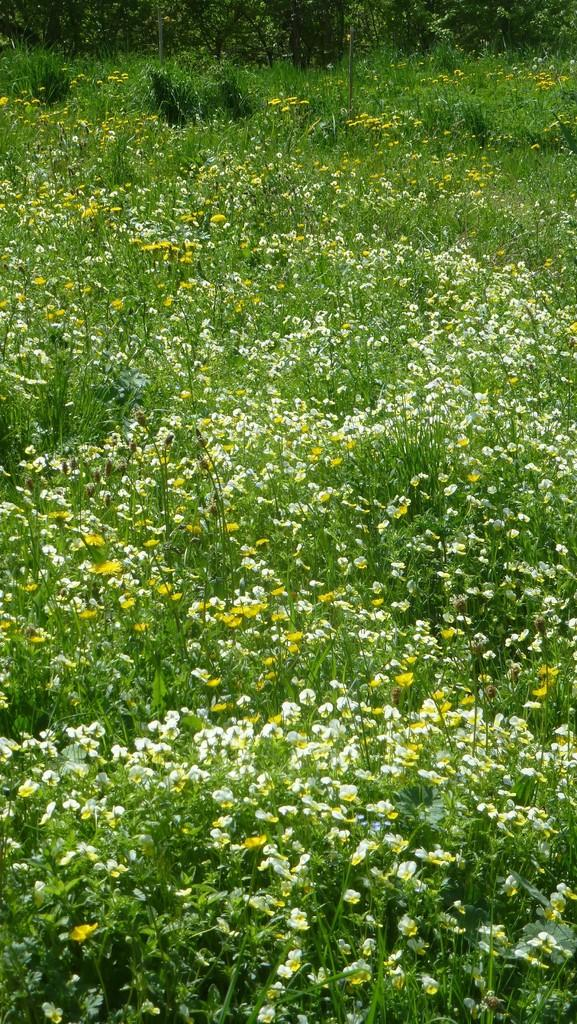What type of living organisms can be seen in the image? Plants and flowers are visible in the image. Can you describe the specific plants or flowers in the image? Unfortunately, the facts provided do not give specific details about the plants or flowers in the image. What might be the purpose of these plants or flowers in the image? The purpose of the plants and flowers in the image is not mentioned in the facts provided. What is the health rating of the airport in the image? There is no airport present in the image, so it is not possible to determine its health rating. 